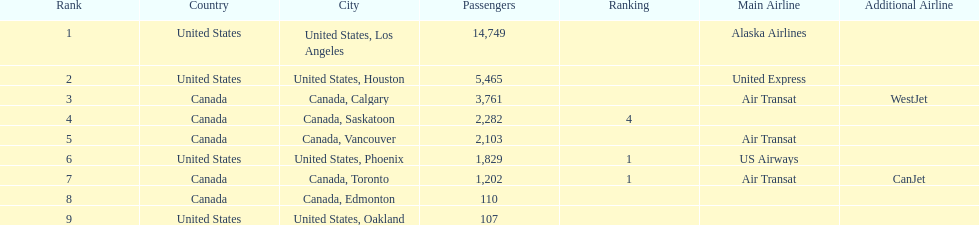Which airline carries the most passengers? Alaska Airlines. 